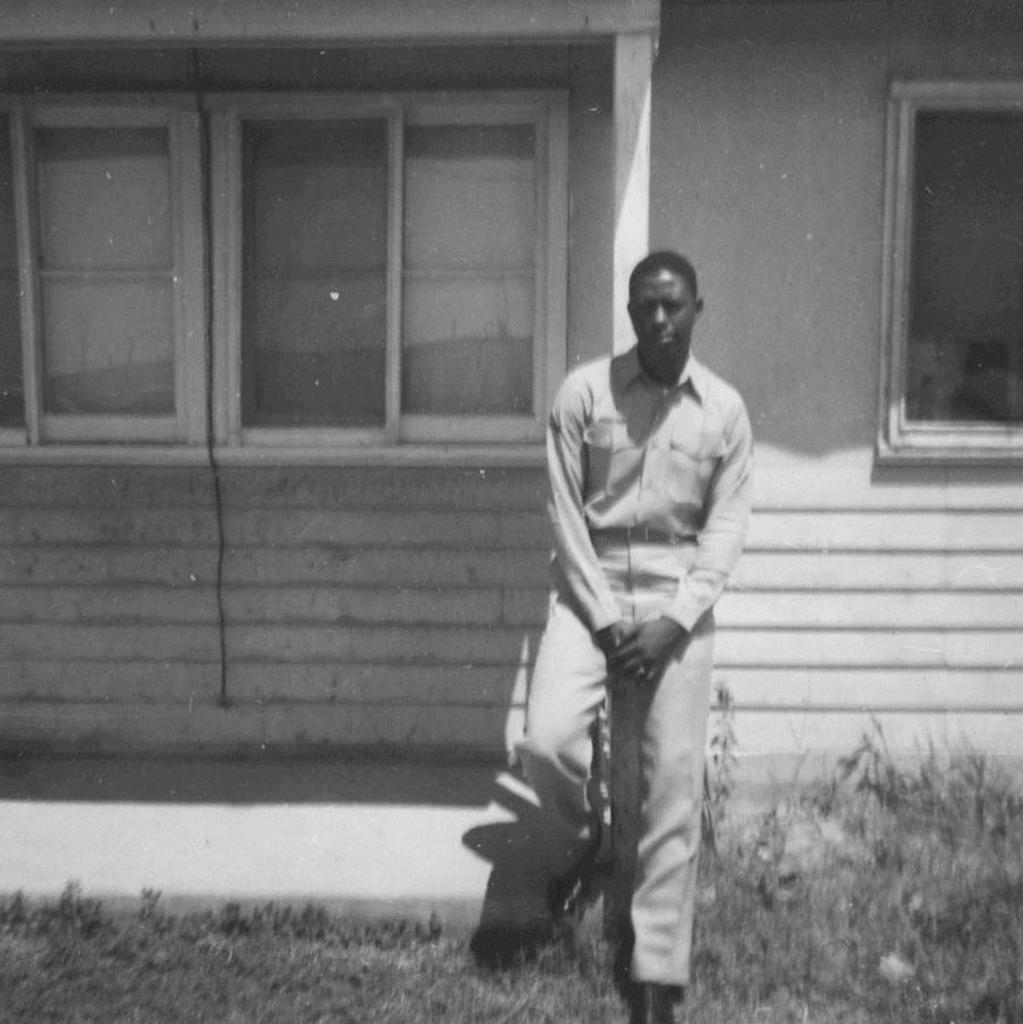What is the main subject of the image? There is a person standing in the image. What type of natural environment is visible in the image? There is grass in the image. What other types of vegetation can be seen in the image? There are plants in the image. What type of structure is visible in the image? There is a house with windows in the image. How many friends is the person standing with in the image? There is no indication of any friends in the image; only one person is visible. What type of step is the person standing on in the image? There is no mention of a step in the image; the person is standing on grass. 